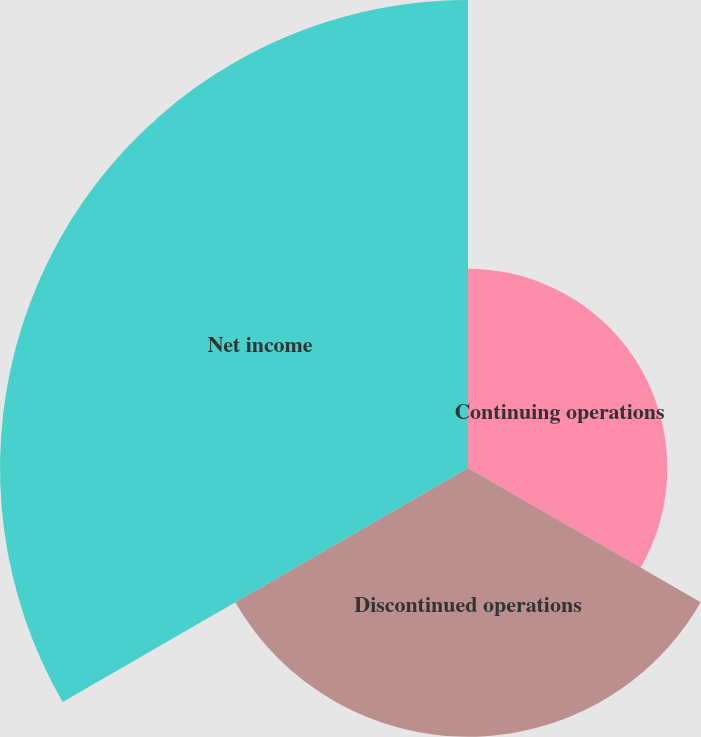Convert chart to OTSL. <chart><loc_0><loc_0><loc_500><loc_500><pie_chart><fcel>Continuing operations<fcel>Discontinued operations<fcel>Net income<nl><fcel>21.29%<fcel>28.71%<fcel>50.0%<nl></chart> 